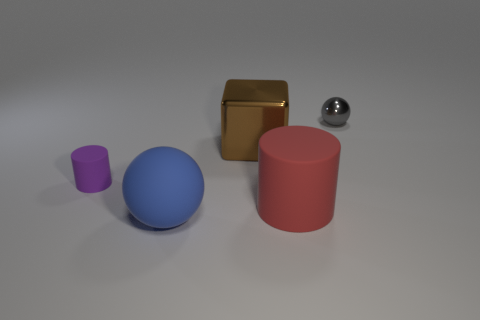What number of blue objects are tiny matte things or rubber things?
Make the answer very short. 1. There is a tiny shiny object; how many purple matte cylinders are behind it?
Keep it short and to the point. 0. How big is the metal thing that is on the left side of the matte cylinder on the right side of the matte object behind the red cylinder?
Ensure brevity in your answer.  Large. Are there any matte cylinders to the left of the big thing that is in front of the matte object on the right side of the metallic block?
Give a very brief answer. Yes. Are there more brown cubes than rubber blocks?
Provide a succinct answer. Yes. What is the color of the small object that is to the right of the big brown object?
Give a very brief answer. Gray. Is the number of large matte balls that are to the left of the tiny purple thing greater than the number of big purple metallic things?
Give a very brief answer. No. Is the material of the blue object the same as the tiny purple cylinder?
Ensure brevity in your answer.  Yes. How many other things are the same shape as the large metallic object?
Offer a terse response. 0. Are there any other things that are the same material as the red cylinder?
Make the answer very short. Yes. 